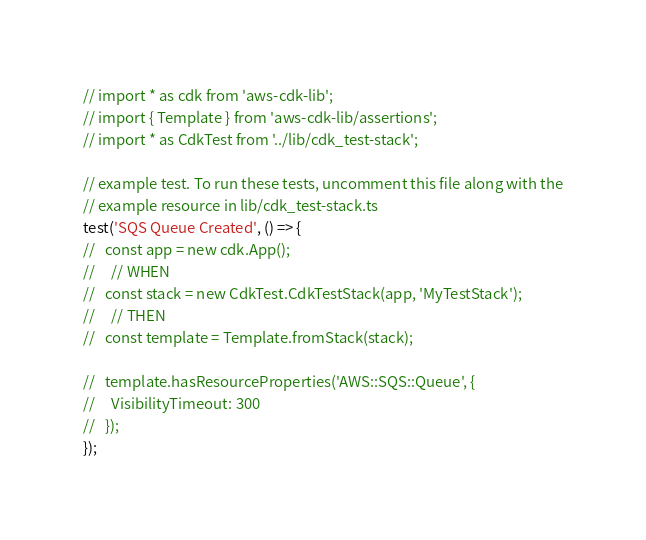Convert code to text. <code><loc_0><loc_0><loc_500><loc_500><_TypeScript_>// import * as cdk from 'aws-cdk-lib';
// import { Template } from 'aws-cdk-lib/assertions';
// import * as CdkTest from '../lib/cdk_test-stack';

// example test. To run these tests, uncomment this file along with the
// example resource in lib/cdk_test-stack.ts
test('SQS Queue Created', () => {
//   const app = new cdk.App();
//     // WHEN
//   const stack = new CdkTest.CdkTestStack(app, 'MyTestStack');
//     // THEN
//   const template = Template.fromStack(stack);

//   template.hasResourceProperties('AWS::SQS::Queue', {
//     VisibilityTimeout: 300
//   });
});
</code> 